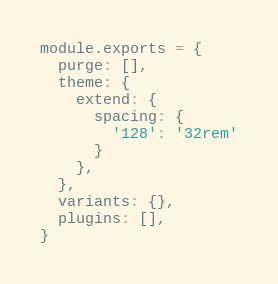Convert code to text. <code><loc_0><loc_0><loc_500><loc_500><_JavaScript_>module.exports = {
  purge: [],
  theme: {
    extend: {
      spacing: {
        '128': '32rem'
      }
    },
  },
  variants: {},
  plugins: [],
}
</code> 